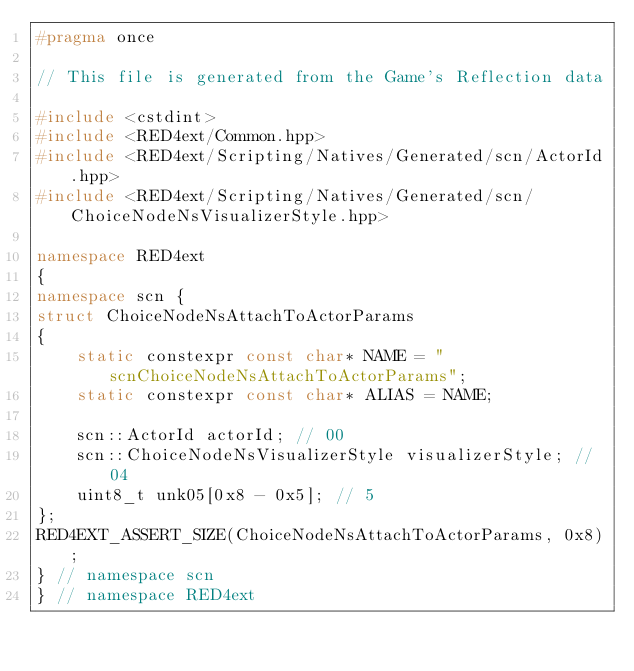Convert code to text. <code><loc_0><loc_0><loc_500><loc_500><_C++_>#pragma once

// This file is generated from the Game's Reflection data

#include <cstdint>
#include <RED4ext/Common.hpp>
#include <RED4ext/Scripting/Natives/Generated/scn/ActorId.hpp>
#include <RED4ext/Scripting/Natives/Generated/scn/ChoiceNodeNsVisualizerStyle.hpp>

namespace RED4ext
{
namespace scn { 
struct ChoiceNodeNsAttachToActorParams
{
    static constexpr const char* NAME = "scnChoiceNodeNsAttachToActorParams";
    static constexpr const char* ALIAS = NAME;

    scn::ActorId actorId; // 00
    scn::ChoiceNodeNsVisualizerStyle visualizerStyle; // 04
    uint8_t unk05[0x8 - 0x5]; // 5
};
RED4EXT_ASSERT_SIZE(ChoiceNodeNsAttachToActorParams, 0x8);
} // namespace scn
} // namespace RED4ext
</code> 